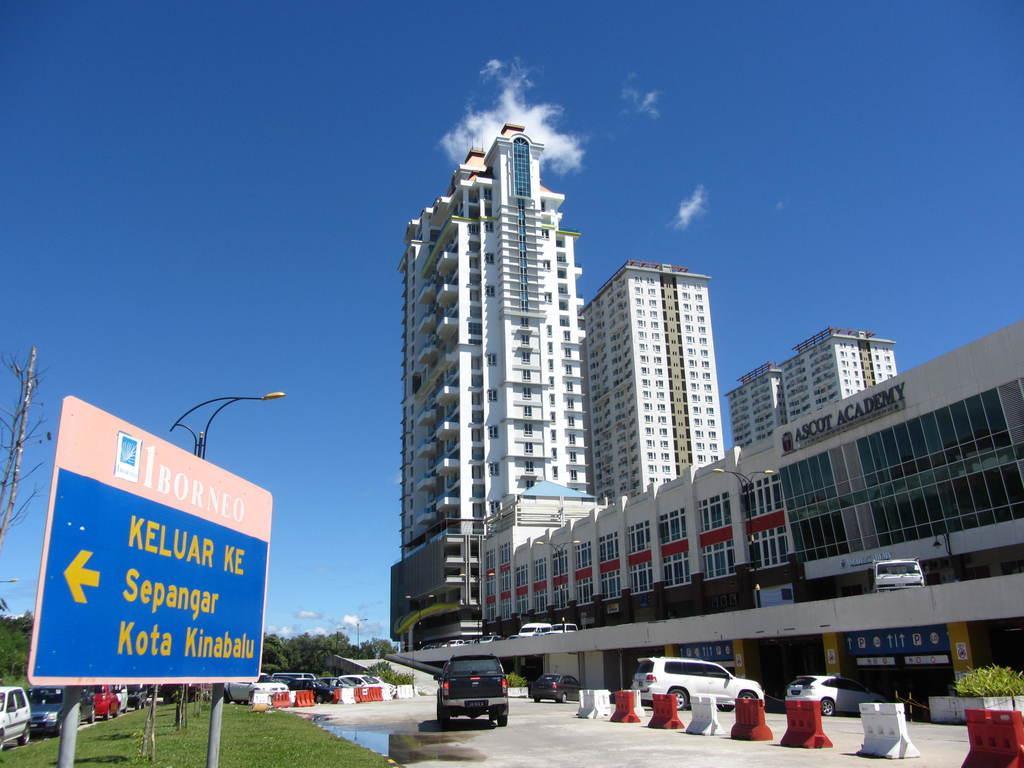Can you describe this image briefly? In the picture I can see a blue color board on which we can see some text is written, we can see vehicles parked here, we can see light poles on the left side of the an image and on the right side of image, we can see road barriers, a few more vehicles parked here, we can see tower buildings and the blue sky with clouds in the background. 